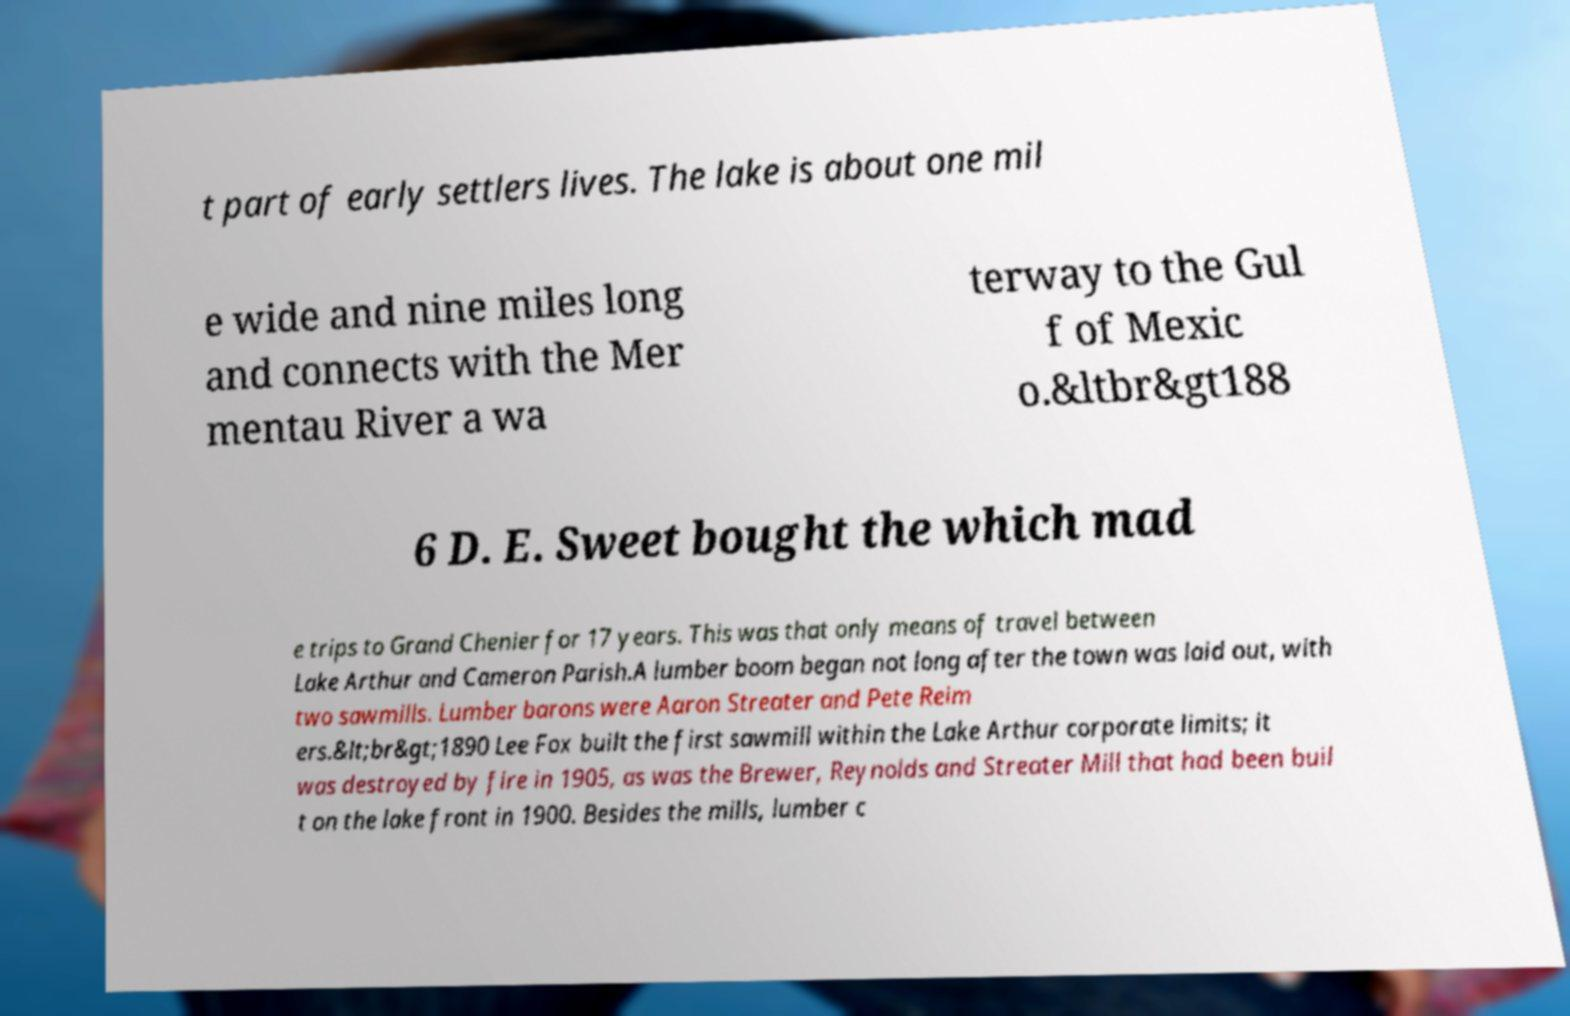Could you extract and type out the text from this image? t part of early settlers lives. The lake is about one mil e wide and nine miles long and connects with the Mer mentau River a wa terway to the Gul f of Mexic o.&ltbr&gt188 6 D. E. Sweet bought the which mad e trips to Grand Chenier for 17 years. This was that only means of travel between Lake Arthur and Cameron Parish.A lumber boom began not long after the town was laid out, with two sawmills. Lumber barons were Aaron Streater and Pete Reim ers.&lt;br&gt;1890 Lee Fox built the first sawmill within the Lake Arthur corporate limits; it was destroyed by fire in 1905, as was the Brewer, Reynolds and Streater Mill that had been buil t on the lake front in 1900. Besides the mills, lumber c 